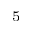Convert formula to latex. <formula><loc_0><loc_0><loc_500><loc_500>^ { 5 }</formula> 